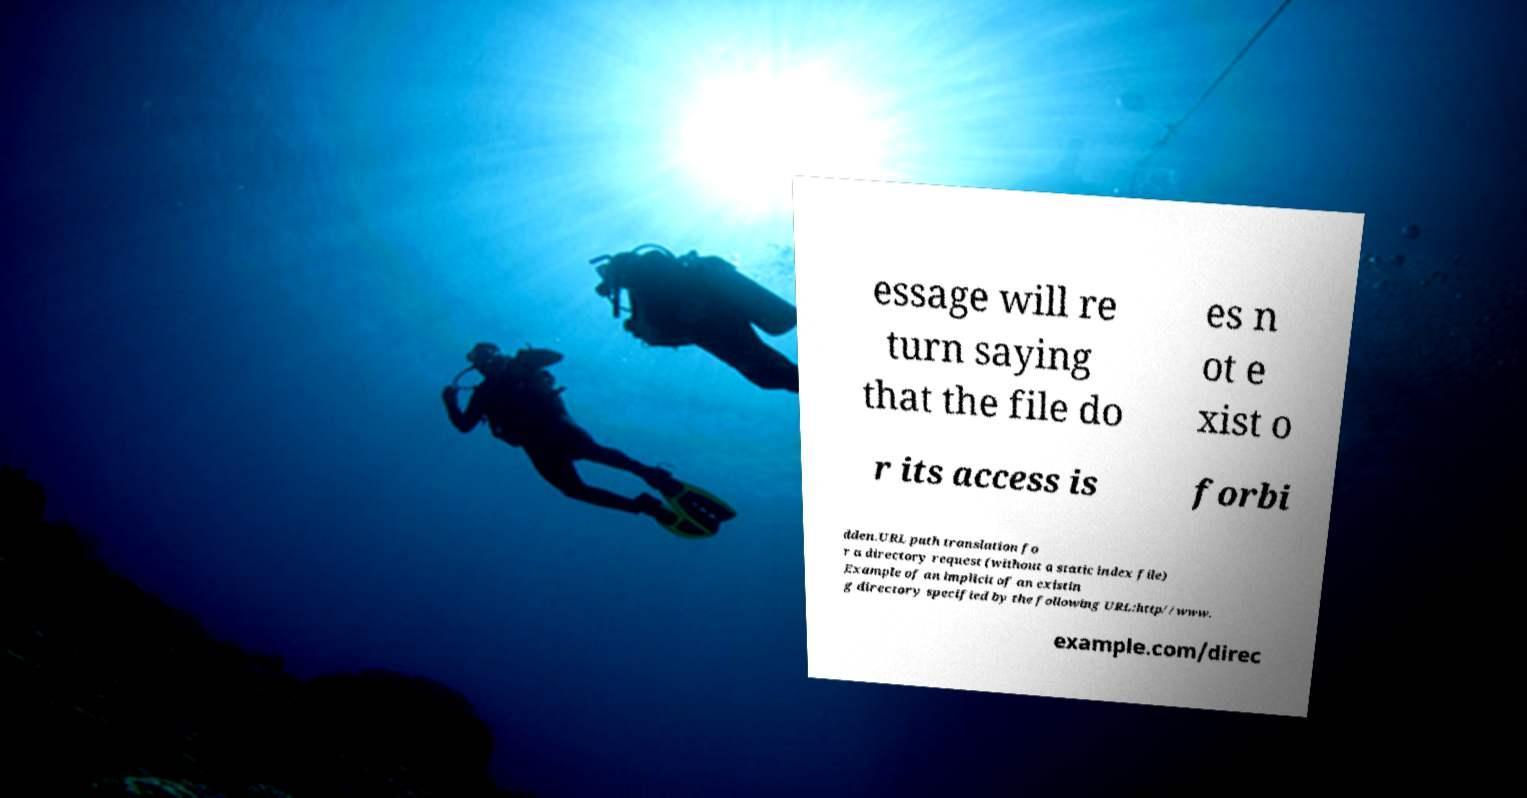Can you accurately transcribe the text from the provided image for me? essage will re turn saying that the file do es n ot e xist o r its access is forbi dden.URL path translation fo r a directory request (without a static index file) Example of an implicit of an existin g directory specified by the following URL:http//www. example.com/direc 